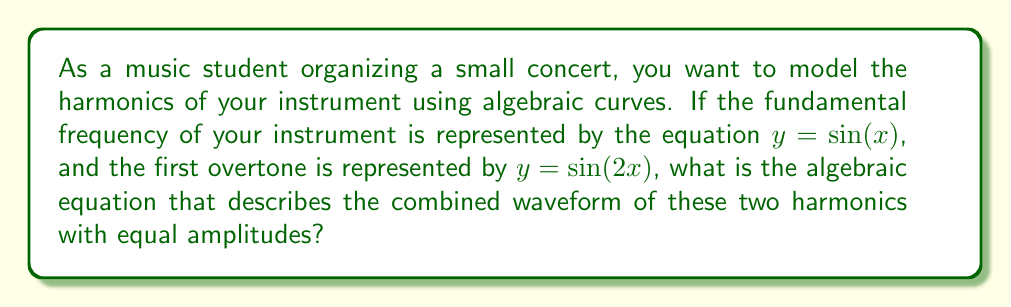Help me with this question. Let's approach this step-by-step:

1) The fundamental frequency is given by $y_1 = \sin(x)$

2) The first overtone is given by $y_2 = \sin(2x)$

3) To combine these waves with equal amplitudes, we add them together:

   $y = y_1 + y_2 = \sin(x) + \sin(2x)$

4) This is our combined waveform, but it's not yet in algebraic form. To convert this to an algebraic equation, we need to use trigonometric identities.

5) We can use the trigonometric identity for the sum of sines:

   $\sin(A) + \sin(B) = 2 \sin(\frac{A+B}{2}) \cos(\frac{A-B}{2})$

6) In our case, $A = x$ and $B = 2x$. Let's substitute:

   $y = 2 \sin(\frac{x+2x}{2}) \cos(\frac{x-2x}{2})$

7) Simplify:

   $y = 2 \sin(\frac{3x}{2}) \cos(-\frac{x}{2})$

8) Note that $\cos(-\frac{x}{2}) = \cos(\frac{x}{2})$ because cosine is an even function.

9) Therefore, our final algebraic equation is:

   $y = 2 \sin(\frac{3x}{2}) \cos(\frac{x}{2})$

This equation represents the combined waveform of the fundamental frequency and its first overtone with equal amplitudes.
Answer: $y = 2 \sin(\frac{3x}{2}) \cos(\frac{x}{2})$ 